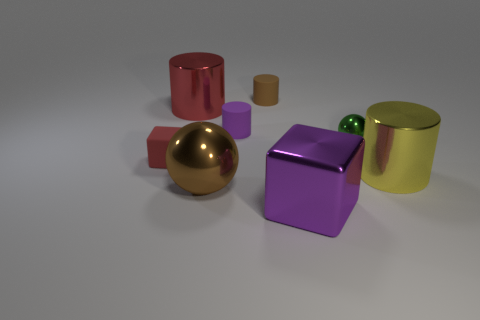Add 1 balls. How many objects exist? 9 Subtract all spheres. How many objects are left? 6 Subtract 0 gray spheres. How many objects are left? 8 Subtract all red balls. Subtract all large brown objects. How many objects are left? 7 Add 1 big purple metallic objects. How many big purple metallic objects are left? 2 Add 3 tiny brown cylinders. How many tiny brown cylinders exist? 4 